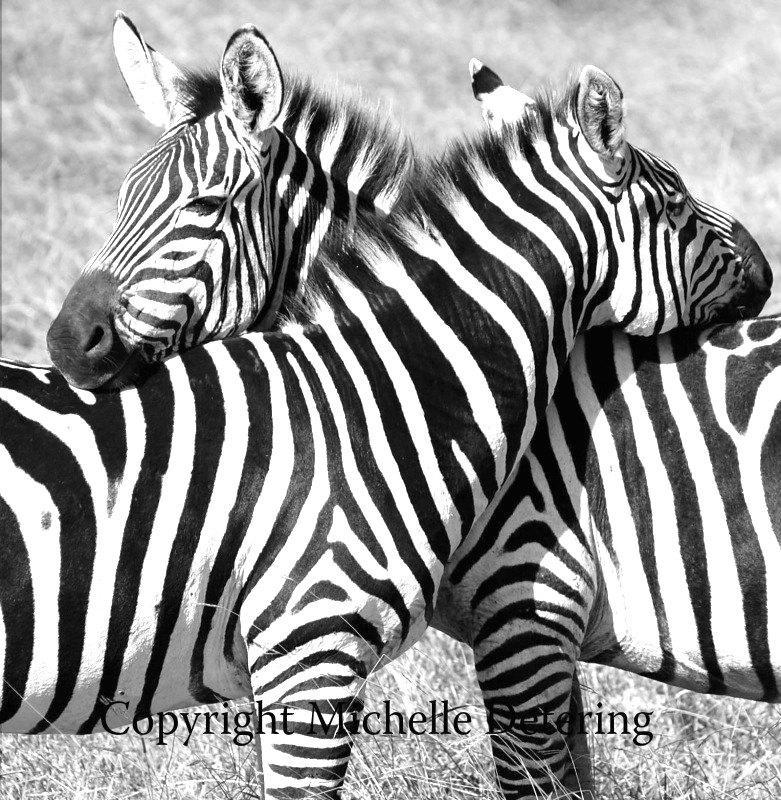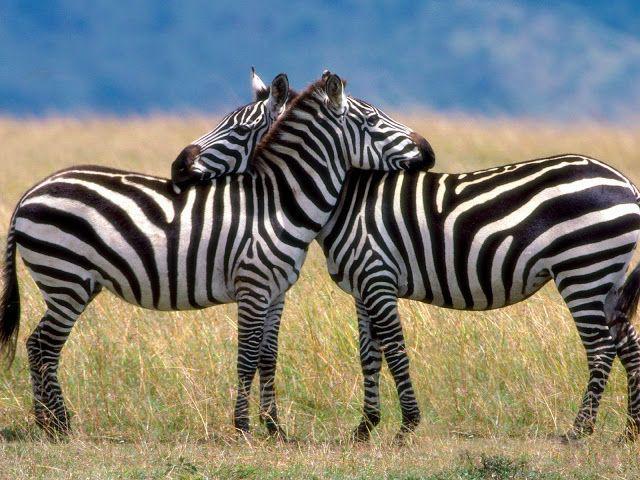The first image is the image on the left, the second image is the image on the right. Examine the images to the left and right. Is the description "The two zebras are standing together in the field resting their heads on one another." accurate? Answer yes or no. Yes. 